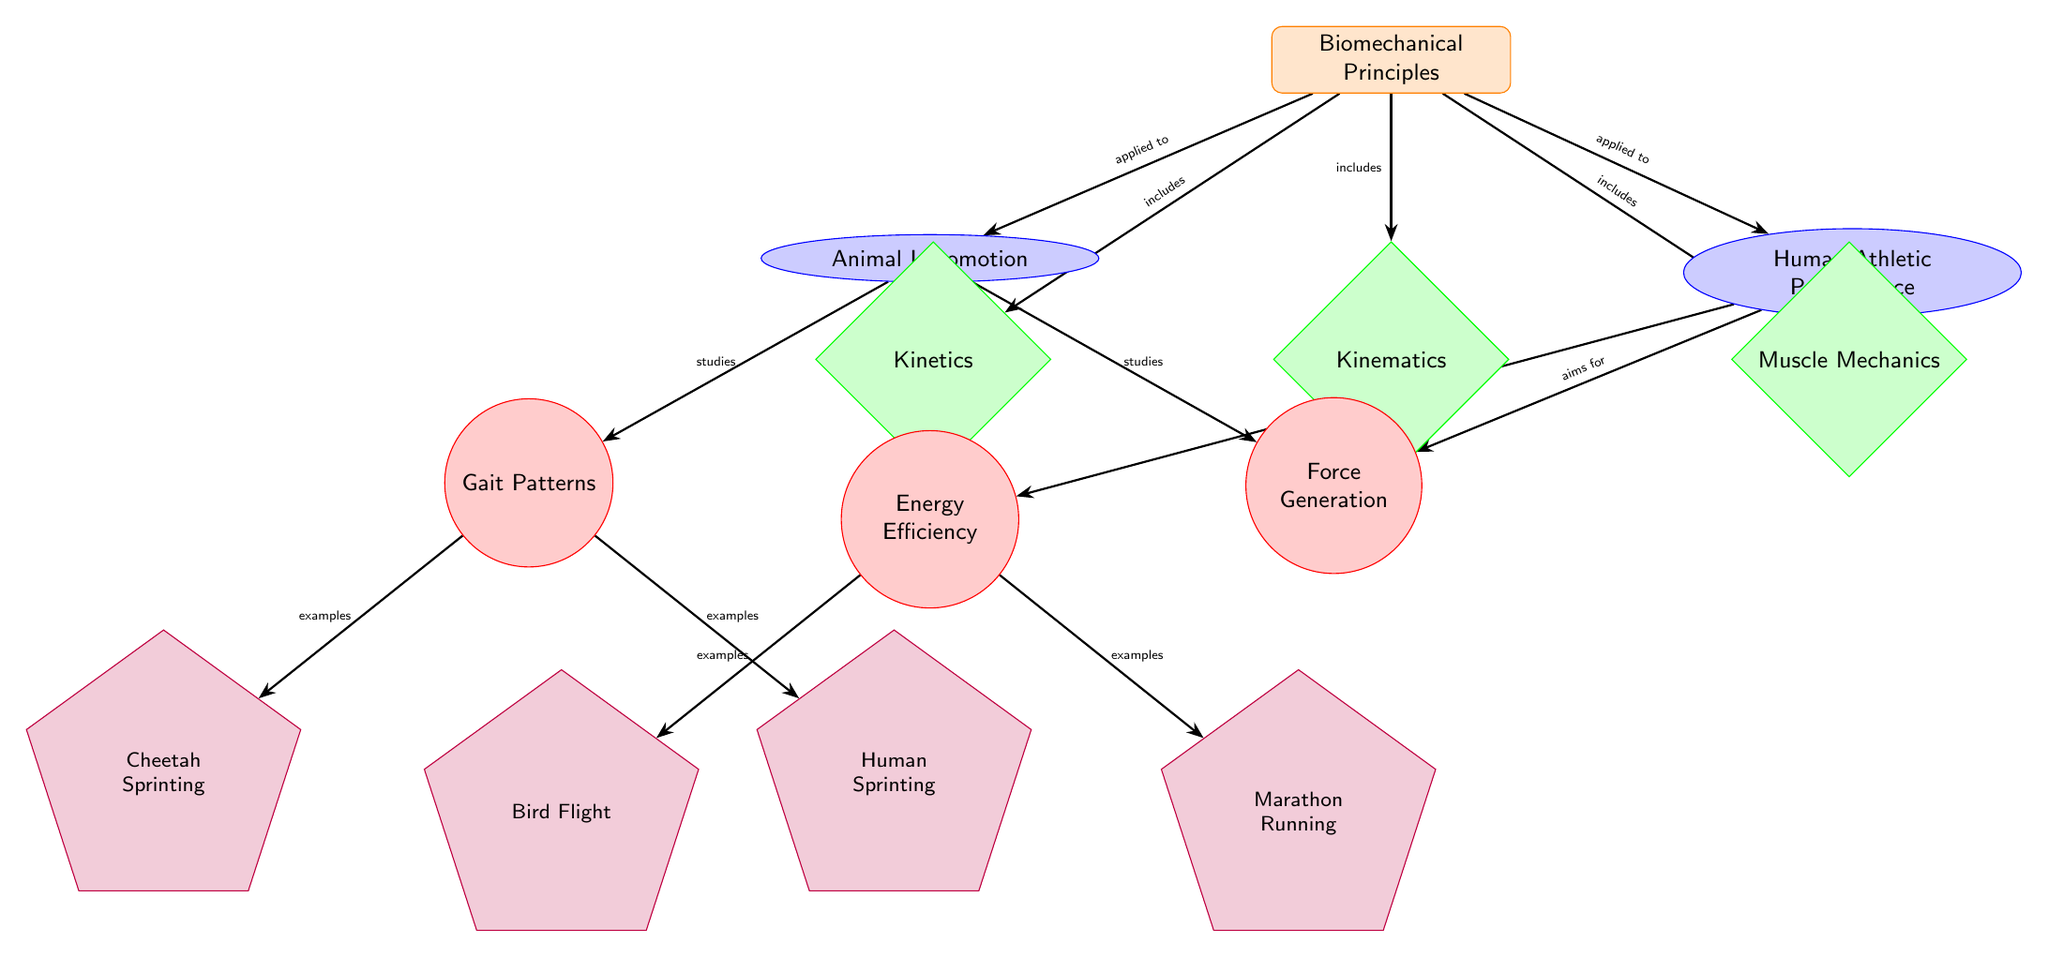What are the two main categories of biomechanical principles in the diagram? The diagram shows two main categories under 'Biomechanical Principles': 'Animal Locomotion' and 'Human Athletic Performance'. These are presented as separate nodes branching from the 'Biomechanical Principles' concept node.
Answer: Animal Locomotion, Human Athletic Performance How many subconcepts are included under 'Biomechanical Principles'? The diagram provides three subconcepts under 'Biomechanical Principles': 'Kinematics', 'Kinetics', and 'Muscle Mechanics'. Each is listed as a separate node connected to the main concept.
Answer: 3 What is an example of a gait pattern? The diagram lists 'Cheetah Sprinting' and 'Human Sprinting' as examples of gait patterns under the 'Gait Patterns' node. Both are specific types of locomotory movements relevant to the biomechanical study.
Answer: Cheetah Sprinting Which aspect of human athletic performance aims for energy efficiency? The 'Energy Efficiency' node is clearly stated under 'Human Athletic Performance', indicating it's an important consideration in human sports science and athletic training through applied biomechanics.
Answer: Energy Efficiency What biomechanical principle is used to study force generation in animals? The 'Force Generation' node under the 'Animal Locomotion' category explicitly indicates that force generation is a biomechanical principle studied in how animals move.
Answer: Force Generation What is the relationship between 'Kinematics' and 'Biomechanical Principles'? The 'Kinematics' node is directly linked to 'Biomechanical Principles', indicating that kinematics is one of the components that constitute the broader field of biomechanical principles.
Answer: includes Which example of energy efficiency is associated with marathon running? 'Marathon Running' is linked under the 'Energy Efficiency' node as a specific example where humans exhibit energy-efficient locomotion akin to principles studied in animal movement sciences.
Answer: Marathon Running How does 'Animal Locomotion' relate to 'Force Generation'? The relationship is indicated by an arrow connecting 'Animal Locomotion' to 'Force Generation', showing that 'Animal Locomotion' studies force generation as part of its exploration into biomechanical principles.
Answer: studies What color is used for the 'Muscle Mechanics' subconcept? The 'Muscle Mechanics' subconcept is filled with a light green color within the diagram, distinguishing it visually from other parts of the structure.
Answer: green 